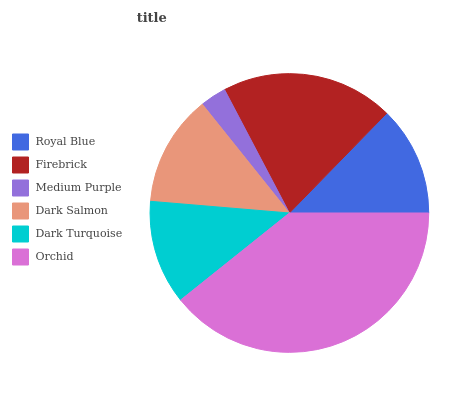Is Medium Purple the minimum?
Answer yes or no. Yes. Is Orchid the maximum?
Answer yes or no. Yes. Is Firebrick the minimum?
Answer yes or no. No. Is Firebrick the maximum?
Answer yes or no. No. Is Firebrick greater than Royal Blue?
Answer yes or no. Yes. Is Royal Blue less than Firebrick?
Answer yes or no. Yes. Is Royal Blue greater than Firebrick?
Answer yes or no. No. Is Firebrick less than Royal Blue?
Answer yes or no. No. Is Dark Salmon the high median?
Answer yes or no. Yes. Is Royal Blue the low median?
Answer yes or no. Yes. Is Royal Blue the high median?
Answer yes or no. No. Is Medium Purple the low median?
Answer yes or no. No. 